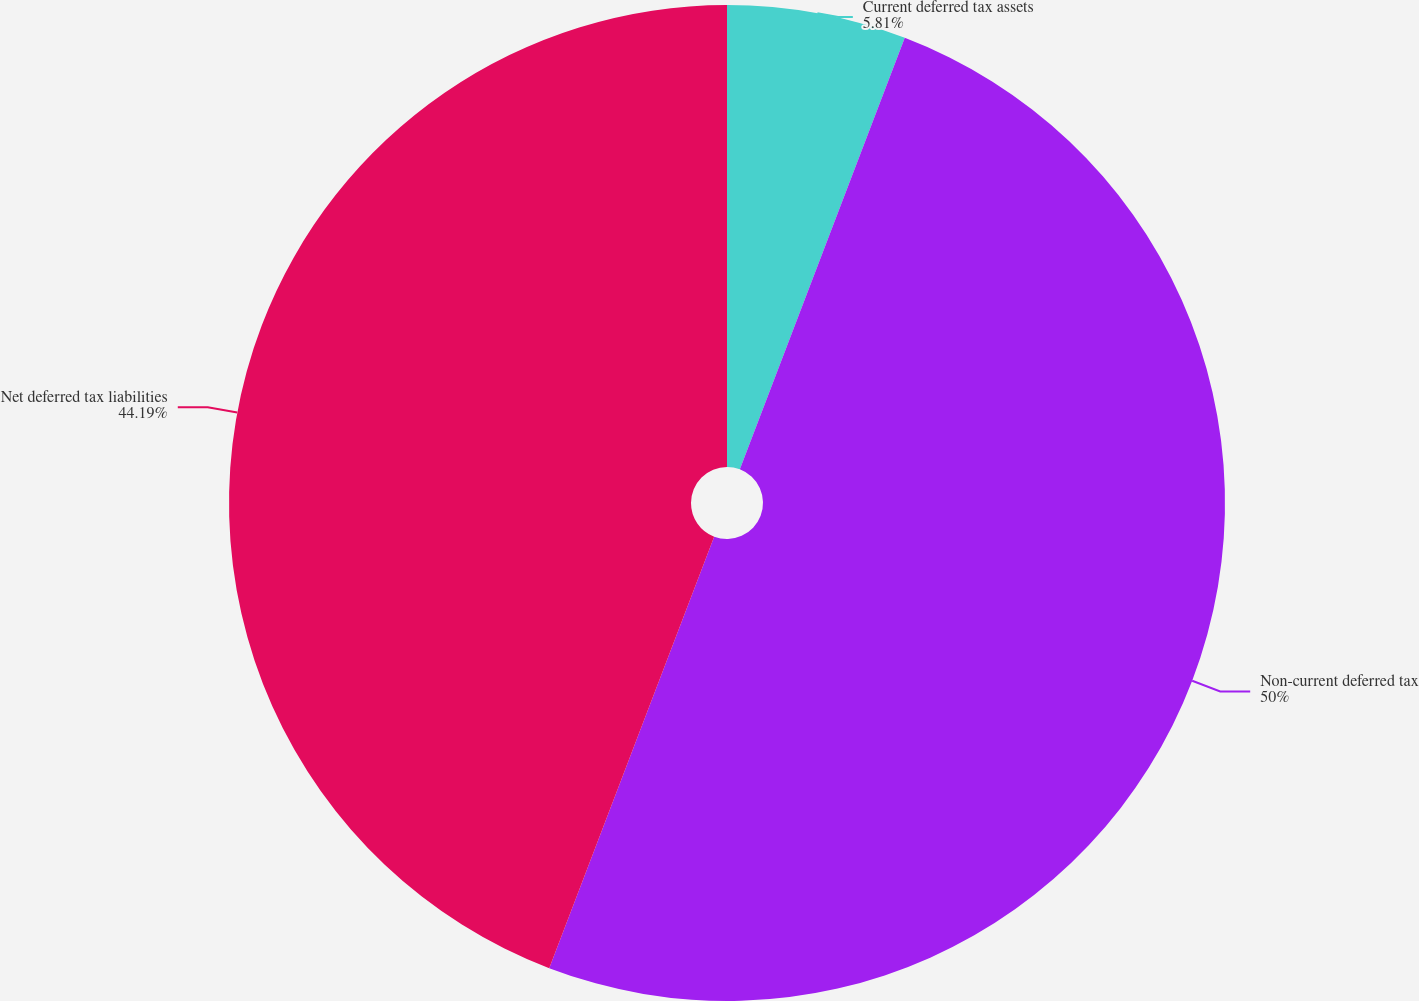Convert chart to OTSL. <chart><loc_0><loc_0><loc_500><loc_500><pie_chart><fcel>Current deferred tax assets<fcel>Non-current deferred tax<fcel>Net deferred tax liabilities<nl><fcel>5.81%<fcel>50.0%<fcel>44.19%<nl></chart> 